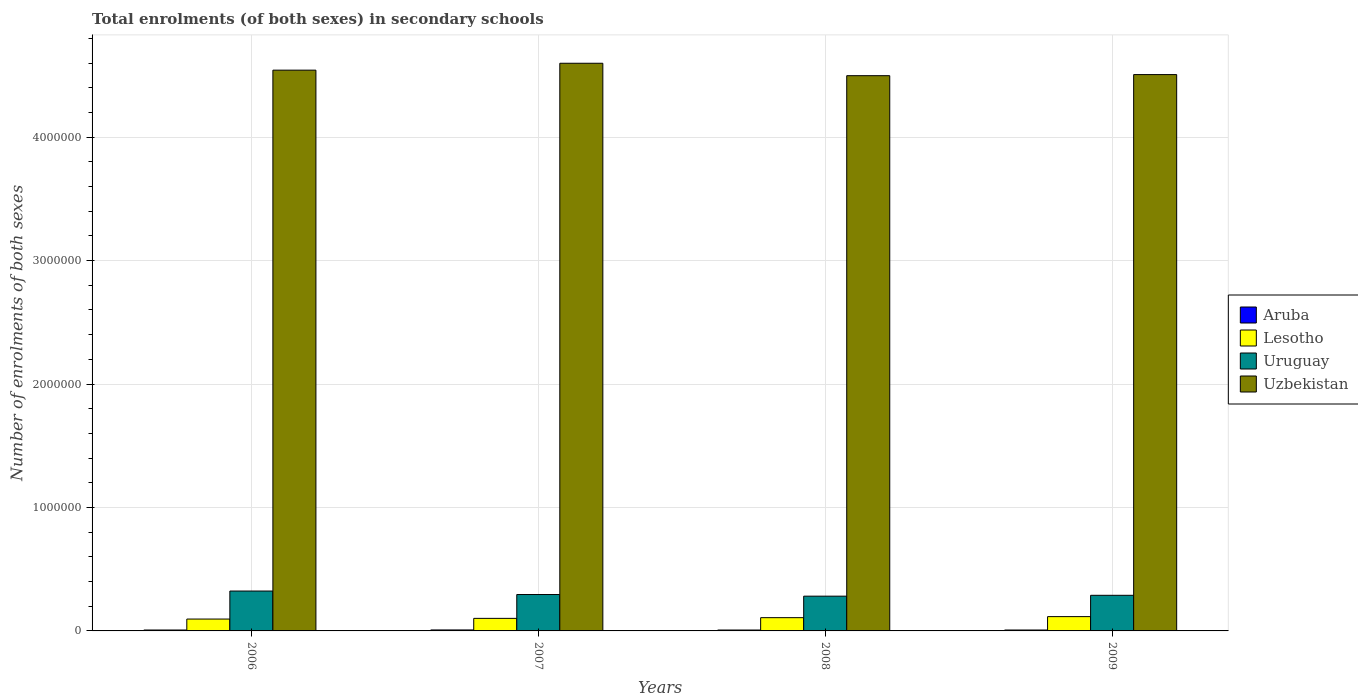How many different coloured bars are there?
Your answer should be compact. 4. In how many cases, is the number of bars for a given year not equal to the number of legend labels?
Your answer should be compact. 0. What is the number of enrolments in secondary schools in Uruguay in 2009?
Provide a short and direct response. 2.88e+05. Across all years, what is the maximum number of enrolments in secondary schools in Uzbekistan?
Your answer should be compact. 4.60e+06. Across all years, what is the minimum number of enrolments in secondary schools in Uzbekistan?
Ensure brevity in your answer.  4.50e+06. In which year was the number of enrolments in secondary schools in Uruguay maximum?
Offer a very short reply. 2006. What is the total number of enrolments in secondary schools in Lesotho in the graph?
Your answer should be compact. 4.21e+05. What is the difference between the number of enrolments in secondary schools in Uzbekistan in 2007 and that in 2008?
Your answer should be very brief. 1.01e+05. What is the difference between the number of enrolments in secondary schools in Lesotho in 2007 and the number of enrolments in secondary schools in Uzbekistan in 2008?
Your answer should be very brief. -4.40e+06. What is the average number of enrolments in secondary schools in Lesotho per year?
Your response must be concise. 1.05e+05. In the year 2008, what is the difference between the number of enrolments in secondary schools in Uruguay and number of enrolments in secondary schools in Lesotho?
Your answer should be very brief. 1.74e+05. What is the ratio of the number of enrolments in secondary schools in Lesotho in 2007 to that in 2008?
Keep it short and to the point. 0.95. What is the difference between the highest and the second highest number of enrolments in secondary schools in Uruguay?
Your answer should be compact. 2.82e+04. What is the difference between the highest and the lowest number of enrolments in secondary schools in Uruguay?
Keep it short and to the point. 4.14e+04. In how many years, is the number of enrolments in secondary schools in Aruba greater than the average number of enrolments in secondary schools in Aruba taken over all years?
Your response must be concise. 1. Is the sum of the number of enrolments in secondary schools in Lesotho in 2008 and 2009 greater than the maximum number of enrolments in secondary schools in Uruguay across all years?
Offer a very short reply. No. What does the 2nd bar from the left in 2008 represents?
Provide a short and direct response. Lesotho. What does the 2nd bar from the right in 2007 represents?
Offer a terse response. Uruguay. How many bars are there?
Provide a succinct answer. 16. Are all the bars in the graph horizontal?
Your answer should be compact. No. What is the difference between two consecutive major ticks on the Y-axis?
Provide a short and direct response. 1.00e+06. Are the values on the major ticks of Y-axis written in scientific E-notation?
Make the answer very short. No. How many legend labels are there?
Make the answer very short. 4. What is the title of the graph?
Give a very brief answer. Total enrolments (of both sexes) in secondary schools. Does "Denmark" appear as one of the legend labels in the graph?
Offer a terse response. No. What is the label or title of the X-axis?
Offer a terse response. Years. What is the label or title of the Y-axis?
Offer a terse response. Number of enrolments of both sexes. What is the Number of enrolments of both sexes of Aruba in 2006?
Provide a short and direct response. 7439. What is the Number of enrolments of both sexes of Lesotho in 2006?
Your response must be concise. 9.61e+04. What is the Number of enrolments of both sexes of Uruguay in 2006?
Give a very brief answer. 3.23e+05. What is the Number of enrolments of both sexes in Uzbekistan in 2006?
Offer a very short reply. 4.54e+06. What is the Number of enrolments of both sexes of Aruba in 2007?
Ensure brevity in your answer.  7853. What is the Number of enrolments of both sexes of Lesotho in 2007?
Offer a terse response. 1.02e+05. What is the Number of enrolments of both sexes in Uruguay in 2007?
Your response must be concise. 2.95e+05. What is the Number of enrolments of both sexes in Uzbekistan in 2007?
Offer a very short reply. 4.60e+06. What is the Number of enrolments of both sexes in Aruba in 2008?
Offer a terse response. 7270. What is the Number of enrolments of both sexes in Lesotho in 2008?
Give a very brief answer. 1.07e+05. What is the Number of enrolments of both sexes of Uruguay in 2008?
Provide a short and direct response. 2.82e+05. What is the Number of enrolments of both sexes in Uzbekistan in 2008?
Offer a terse response. 4.50e+06. What is the Number of enrolments of both sexes of Aruba in 2009?
Give a very brief answer. 7439. What is the Number of enrolments of both sexes of Lesotho in 2009?
Ensure brevity in your answer.  1.16e+05. What is the Number of enrolments of both sexes in Uruguay in 2009?
Your response must be concise. 2.88e+05. What is the Number of enrolments of both sexes of Uzbekistan in 2009?
Make the answer very short. 4.51e+06. Across all years, what is the maximum Number of enrolments of both sexes of Aruba?
Provide a short and direct response. 7853. Across all years, what is the maximum Number of enrolments of both sexes of Lesotho?
Your response must be concise. 1.16e+05. Across all years, what is the maximum Number of enrolments of both sexes in Uruguay?
Offer a terse response. 3.23e+05. Across all years, what is the maximum Number of enrolments of both sexes of Uzbekistan?
Offer a very short reply. 4.60e+06. Across all years, what is the minimum Number of enrolments of both sexes in Aruba?
Ensure brevity in your answer.  7270. Across all years, what is the minimum Number of enrolments of both sexes of Lesotho?
Your answer should be very brief. 9.61e+04. Across all years, what is the minimum Number of enrolments of both sexes of Uruguay?
Make the answer very short. 2.82e+05. Across all years, what is the minimum Number of enrolments of both sexes of Uzbekistan?
Give a very brief answer. 4.50e+06. What is the total Number of enrolments of both sexes of Aruba in the graph?
Keep it short and to the point. 3.00e+04. What is the total Number of enrolments of both sexes of Lesotho in the graph?
Keep it short and to the point. 4.21e+05. What is the total Number of enrolments of both sexes of Uruguay in the graph?
Provide a succinct answer. 1.19e+06. What is the total Number of enrolments of both sexes in Uzbekistan in the graph?
Your response must be concise. 1.81e+07. What is the difference between the Number of enrolments of both sexes of Aruba in 2006 and that in 2007?
Your answer should be compact. -414. What is the difference between the Number of enrolments of both sexes of Lesotho in 2006 and that in 2007?
Your answer should be very brief. -5665. What is the difference between the Number of enrolments of both sexes in Uruguay in 2006 and that in 2007?
Your answer should be very brief. 2.82e+04. What is the difference between the Number of enrolments of both sexes of Uzbekistan in 2006 and that in 2007?
Your answer should be very brief. -5.59e+04. What is the difference between the Number of enrolments of both sexes of Aruba in 2006 and that in 2008?
Make the answer very short. 169. What is the difference between the Number of enrolments of both sexes of Lesotho in 2006 and that in 2008?
Provide a succinct answer. -1.12e+04. What is the difference between the Number of enrolments of both sexes in Uruguay in 2006 and that in 2008?
Ensure brevity in your answer.  4.14e+04. What is the difference between the Number of enrolments of both sexes in Uzbekistan in 2006 and that in 2008?
Your answer should be very brief. 4.48e+04. What is the difference between the Number of enrolments of both sexes of Lesotho in 2006 and that in 2009?
Offer a very short reply. -1.97e+04. What is the difference between the Number of enrolments of both sexes in Uruguay in 2006 and that in 2009?
Provide a short and direct response. 3.45e+04. What is the difference between the Number of enrolments of both sexes of Uzbekistan in 2006 and that in 2009?
Offer a terse response. 3.59e+04. What is the difference between the Number of enrolments of both sexes of Aruba in 2007 and that in 2008?
Make the answer very short. 583. What is the difference between the Number of enrolments of both sexes in Lesotho in 2007 and that in 2008?
Provide a succinct answer. -5584. What is the difference between the Number of enrolments of both sexes of Uruguay in 2007 and that in 2008?
Offer a very short reply. 1.33e+04. What is the difference between the Number of enrolments of both sexes of Uzbekistan in 2007 and that in 2008?
Ensure brevity in your answer.  1.01e+05. What is the difference between the Number of enrolments of both sexes of Aruba in 2007 and that in 2009?
Ensure brevity in your answer.  414. What is the difference between the Number of enrolments of both sexes of Lesotho in 2007 and that in 2009?
Offer a terse response. -1.41e+04. What is the difference between the Number of enrolments of both sexes of Uruguay in 2007 and that in 2009?
Keep it short and to the point. 6361. What is the difference between the Number of enrolments of both sexes in Uzbekistan in 2007 and that in 2009?
Your answer should be very brief. 9.18e+04. What is the difference between the Number of enrolments of both sexes of Aruba in 2008 and that in 2009?
Offer a terse response. -169. What is the difference between the Number of enrolments of both sexes in Lesotho in 2008 and that in 2009?
Give a very brief answer. -8483. What is the difference between the Number of enrolments of both sexes in Uruguay in 2008 and that in 2009?
Provide a short and direct response. -6898. What is the difference between the Number of enrolments of both sexes in Uzbekistan in 2008 and that in 2009?
Ensure brevity in your answer.  -8854. What is the difference between the Number of enrolments of both sexes of Aruba in 2006 and the Number of enrolments of both sexes of Lesotho in 2007?
Your answer should be compact. -9.43e+04. What is the difference between the Number of enrolments of both sexes in Aruba in 2006 and the Number of enrolments of both sexes in Uruguay in 2007?
Offer a very short reply. -2.87e+05. What is the difference between the Number of enrolments of both sexes in Aruba in 2006 and the Number of enrolments of both sexes in Uzbekistan in 2007?
Provide a succinct answer. -4.59e+06. What is the difference between the Number of enrolments of both sexes of Lesotho in 2006 and the Number of enrolments of both sexes of Uruguay in 2007?
Your answer should be very brief. -1.99e+05. What is the difference between the Number of enrolments of both sexes in Lesotho in 2006 and the Number of enrolments of both sexes in Uzbekistan in 2007?
Offer a terse response. -4.50e+06. What is the difference between the Number of enrolments of both sexes in Uruguay in 2006 and the Number of enrolments of both sexes in Uzbekistan in 2007?
Make the answer very short. -4.28e+06. What is the difference between the Number of enrolments of both sexes in Aruba in 2006 and the Number of enrolments of both sexes in Lesotho in 2008?
Ensure brevity in your answer.  -9.99e+04. What is the difference between the Number of enrolments of both sexes in Aruba in 2006 and the Number of enrolments of both sexes in Uruguay in 2008?
Provide a succinct answer. -2.74e+05. What is the difference between the Number of enrolments of both sexes in Aruba in 2006 and the Number of enrolments of both sexes in Uzbekistan in 2008?
Your answer should be compact. -4.49e+06. What is the difference between the Number of enrolments of both sexes of Lesotho in 2006 and the Number of enrolments of both sexes of Uruguay in 2008?
Provide a short and direct response. -1.86e+05. What is the difference between the Number of enrolments of both sexes in Lesotho in 2006 and the Number of enrolments of both sexes in Uzbekistan in 2008?
Make the answer very short. -4.40e+06. What is the difference between the Number of enrolments of both sexes of Uruguay in 2006 and the Number of enrolments of both sexes of Uzbekistan in 2008?
Make the answer very short. -4.17e+06. What is the difference between the Number of enrolments of both sexes in Aruba in 2006 and the Number of enrolments of both sexes in Lesotho in 2009?
Ensure brevity in your answer.  -1.08e+05. What is the difference between the Number of enrolments of both sexes of Aruba in 2006 and the Number of enrolments of both sexes of Uruguay in 2009?
Ensure brevity in your answer.  -2.81e+05. What is the difference between the Number of enrolments of both sexes of Aruba in 2006 and the Number of enrolments of both sexes of Uzbekistan in 2009?
Your answer should be very brief. -4.50e+06. What is the difference between the Number of enrolments of both sexes of Lesotho in 2006 and the Number of enrolments of both sexes of Uruguay in 2009?
Your answer should be very brief. -1.92e+05. What is the difference between the Number of enrolments of both sexes of Lesotho in 2006 and the Number of enrolments of both sexes of Uzbekistan in 2009?
Keep it short and to the point. -4.41e+06. What is the difference between the Number of enrolments of both sexes of Uruguay in 2006 and the Number of enrolments of both sexes of Uzbekistan in 2009?
Give a very brief answer. -4.18e+06. What is the difference between the Number of enrolments of both sexes of Aruba in 2007 and the Number of enrolments of both sexes of Lesotho in 2008?
Offer a terse response. -9.95e+04. What is the difference between the Number of enrolments of both sexes in Aruba in 2007 and the Number of enrolments of both sexes in Uruguay in 2008?
Your answer should be very brief. -2.74e+05. What is the difference between the Number of enrolments of both sexes in Aruba in 2007 and the Number of enrolments of both sexes in Uzbekistan in 2008?
Your answer should be very brief. -4.49e+06. What is the difference between the Number of enrolments of both sexes in Lesotho in 2007 and the Number of enrolments of both sexes in Uruguay in 2008?
Provide a short and direct response. -1.80e+05. What is the difference between the Number of enrolments of both sexes of Lesotho in 2007 and the Number of enrolments of both sexes of Uzbekistan in 2008?
Your answer should be compact. -4.40e+06. What is the difference between the Number of enrolments of both sexes in Uruguay in 2007 and the Number of enrolments of both sexes in Uzbekistan in 2008?
Give a very brief answer. -4.20e+06. What is the difference between the Number of enrolments of both sexes in Aruba in 2007 and the Number of enrolments of both sexes in Lesotho in 2009?
Your answer should be compact. -1.08e+05. What is the difference between the Number of enrolments of both sexes of Aruba in 2007 and the Number of enrolments of both sexes of Uruguay in 2009?
Your answer should be very brief. -2.81e+05. What is the difference between the Number of enrolments of both sexes of Aruba in 2007 and the Number of enrolments of both sexes of Uzbekistan in 2009?
Keep it short and to the point. -4.50e+06. What is the difference between the Number of enrolments of both sexes of Lesotho in 2007 and the Number of enrolments of both sexes of Uruguay in 2009?
Your answer should be very brief. -1.87e+05. What is the difference between the Number of enrolments of both sexes in Lesotho in 2007 and the Number of enrolments of both sexes in Uzbekistan in 2009?
Make the answer very short. -4.40e+06. What is the difference between the Number of enrolments of both sexes of Uruguay in 2007 and the Number of enrolments of both sexes of Uzbekistan in 2009?
Offer a very short reply. -4.21e+06. What is the difference between the Number of enrolments of both sexes in Aruba in 2008 and the Number of enrolments of both sexes in Lesotho in 2009?
Keep it short and to the point. -1.09e+05. What is the difference between the Number of enrolments of both sexes of Aruba in 2008 and the Number of enrolments of both sexes of Uruguay in 2009?
Ensure brevity in your answer.  -2.81e+05. What is the difference between the Number of enrolments of both sexes in Aruba in 2008 and the Number of enrolments of both sexes in Uzbekistan in 2009?
Keep it short and to the point. -4.50e+06. What is the difference between the Number of enrolments of both sexes of Lesotho in 2008 and the Number of enrolments of both sexes of Uruguay in 2009?
Provide a short and direct response. -1.81e+05. What is the difference between the Number of enrolments of both sexes of Lesotho in 2008 and the Number of enrolments of both sexes of Uzbekistan in 2009?
Provide a short and direct response. -4.40e+06. What is the difference between the Number of enrolments of both sexes of Uruguay in 2008 and the Number of enrolments of both sexes of Uzbekistan in 2009?
Provide a short and direct response. -4.22e+06. What is the average Number of enrolments of both sexes of Aruba per year?
Your response must be concise. 7500.25. What is the average Number of enrolments of both sexes of Lesotho per year?
Your response must be concise. 1.05e+05. What is the average Number of enrolments of both sexes in Uruguay per year?
Ensure brevity in your answer.  2.97e+05. What is the average Number of enrolments of both sexes of Uzbekistan per year?
Your answer should be very brief. 4.54e+06. In the year 2006, what is the difference between the Number of enrolments of both sexes in Aruba and Number of enrolments of both sexes in Lesotho?
Keep it short and to the point. -8.86e+04. In the year 2006, what is the difference between the Number of enrolments of both sexes in Aruba and Number of enrolments of both sexes in Uruguay?
Offer a terse response. -3.16e+05. In the year 2006, what is the difference between the Number of enrolments of both sexes of Aruba and Number of enrolments of both sexes of Uzbekistan?
Your answer should be compact. -4.53e+06. In the year 2006, what is the difference between the Number of enrolments of both sexes in Lesotho and Number of enrolments of both sexes in Uruguay?
Make the answer very short. -2.27e+05. In the year 2006, what is the difference between the Number of enrolments of both sexes of Lesotho and Number of enrolments of both sexes of Uzbekistan?
Your response must be concise. -4.45e+06. In the year 2006, what is the difference between the Number of enrolments of both sexes in Uruguay and Number of enrolments of both sexes in Uzbekistan?
Make the answer very short. -4.22e+06. In the year 2007, what is the difference between the Number of enrolments of both sexes of Aruba and Number of enrolments of both sexes of Lesotho?
Your answer should be very brief. -9.39e+04. In the year 2007, what is the difference between the Number of enrolments of both sexes in Aruba and Number of enrolments of both sexes in Uruguay?
Offer a terse response. -2.87e+05. In the year 2007, what is the difference between the Number of enrolments of both sexes of Aruba and Number of enrolments of both sexes of Uzbekistan?
Make the answer very short. -4.59e+06. In the year 2007, what is the difference between the Number of enrolments of both sexes in Lesotho and Number of enrolments of both sexes in Uruguay?
Give a very brief answer. -1.93e+05. In the year 2007, what is the difference between the Number of enrolments of both sexes of Lesotho and Number of enrolments of both sexes of Uzbekistan?
Keep it short and to the point. -4.50e+06. In the year 2007, what is the difference between the Number of enrolments of both sexes of Uruguay and Number of enrolments of both sexes of Uzbekistan?
Provide a succinct answer. -4.30e+06. In the year 2008, what is the difference between the Number of enrolments of both sexes of Aruba and Number of enrolments of both sexes of Lesotho?
Provide a short and direct response. -1.00e+05. In the year 2008, what is the difference between the Number of enrolments of both sexes in Aruba and Number of enrolments of both sexes in Uruguay?
Your answer should be very brief. -2.74e+05. In the year 2008, what is the difference between the Number of enrolments of both sexes in Aruba and Number of enrolments of both sexes in Uzbekistan?
Give a very brief answer. -4.49e+06. In the year 2008, what is the difference between the Number of enrolments of both sexes of Lesotho and Number of enrolments of both sexes of Uruguay?
Ensure brevity in your answer.  -1.74e+05. In the year 2008, what is the difference between the Number of enrolments of both sexes of Lesotho and Number of enrolments of both sexes of Uzbekistan?
Keep it short and to the point. -4.39e+06. In the year 2008, what is the difference between the Number of enrolments of both sexes in Uruguay and Number of enrolments of both sexes in Uzbekistan?
Give a very brief answer. -4.22e+06. In the year 2009, what is the difference between the Number of enrolments of both sexes in Aruba and Number of enrolments of both sexes in Lesotho?
Offer a very short reply. -1.08e+05. In the year 2009, what is the difference between the Number of enrolments of both sexes in Aruba and Number of enrolments of both sexes in Uruguay?
Provide a succinct answer. -2.81e+05. In the year 2009, what is the difference between the Number of enrolments of both sexes of Aruba and Number of enrolments of both sexes of Uzbekistan?
Offer a terse response. -4.50e+06. In the year 2009, what is the difference between the Number of enrolments of both sexes of Lesotho and Number of enrolments of both sexes of Uruguay?
Your response must be concise. -1.73e+05. In the year 2009, what is the difference between the Number of enrolments of both sexes in Lesotho and Number of enrolments of both sexes in Uzbekistan?
Provide a succinct answer. -4.39e+06. In the year 2009, what is the difference between the Number of enrolments of both sexes of Uruguay and Number of enrolments of both sexes of Uzbekistan?
Make the answer very short. -4.22e+06. What is the ratio of the Number of enrolments of both sexes in Aruba in 2006 to that in 2007?
Your response must be concise. 0.95. What is the ratio of the Number of enrolments of both sexes of Lesotho in 2006 to that in 2007?
Your answer should be compact. 0.94. What is the ratio of the Number of enrolments of both sexes of Uruguay in 2006 to that in 2007?
Keep it short and to the point. 1.1. What is the ratio of the Number of enrolments of both sexes of Uzbekistan in 2006 to that in 2007?
Provide a short and direct response. 0.99. What is the ratio of the Number of enrolments of both sexes in Aruba in 2006 to that in 2008?
Give a very brief answer. 1.02. What is the ratio of the Number of enrolments of both sexes in Lesotho in 2006 to that in 2008?
Provide a succinct answer. 0.9. What is the ratio of the Number of enrolments of both sexes of Uruguay in 2006 to that in 2008?
Offer a terse response. 1.15. What is the ratio of the Number of enrolments of both sexes of Uzbekistan in 2006 to that in 2008?
Provide a short and direct response. 1.01. What is the ratio of the Number of enrolments of both sexes of Aruba in 2006 to that in 2009?
Your response must be concise. 1. What is the ratio of the Number of enrolments of both sexes of Lesotho in 2006 to that in 2009?
Ensure brevity in your answer.  0.83. What is the ratio of the Number of enrolments of both sexes in Uruguay in 2006 to that in 2009?
Provide a succinct answer. 1.12. What is the ratio of the Number of enrolments of both sexes in Uzbekistan in 2006 to that in 2009?
Your response must be concise. 1.01. What is the ratio of the Number of enrolments of both sexes of Aruba in 2007 to that in 2008?
Your answer should be very brief. 1.08. What is the ratio of the Number of enrolments of both sexes in Lesotho in 2007 to that in 2008?
Provide a short and direct response. 0.95. What is the ratio of the Number of enrolments of both sexes in Uruguay in 2007 to that in 2008?
Offer a very short reply. 1.05. What is the ratio of the Number of enrolments of both sexes of Uzbekistan in 2007 to that in 2008?
Keep it short and to the point. 1.02. What is the ratio of the Number of enrolments of both sexes in Aruba in 2007 to that in 2009?
Your answer should be compact. 1.06. What is the ratio of the Number of enrolments of both sexes of Lesotho in 2007 to that in 2009?
Offer a very short reply. 0.88. What is the ratio of the Number of enrolments of both sexes of Uruguay in 2007 to that in 2009?
Your response must be concise. 1.02. What is the ratio of the Number of enrolments of both sexes of Uzbekistan in 2007 to that in 2009?
Provide a succinct answer. 1.02. What is the ratio of the Number of enrolments of both sexes of Aruba in 2008 to that in 2009?
Provide a succinct answer. 0.98. What is the ratio of the Number of enrolments of both sexes in Lesotho in 2008 to that in 2009?
Keep it short and to the point. 0.93. What is the ratio of the Number of enrolments of both sexes in Uruguay in 2008 to that in 2009?
Make the answer very short. 0.98. What is the ratio of the Number of enrolments of both sexes in Uzbekistan in 2008 to that in 2009?
Your answer should be compact. 1. What is the difference between the highest and the second highest Number of enrolments of both sexes in Aruba?
Ensure brevity in your answer.  414. What is the difference between the highest and the second highest Number of enrolments of both sexes of Lesotho?
Your response must be concise. 8483. What is the difference between the highest and the second highest Number of enrolments of both sexes in Uruguay?
Make the answer very short. 2.82e+04. What is the difference between the highest and the second highest Number of enrolments of both sexes of Uzbekistan?
Your answer should be compact. 5.59e+04. What is the difference between the highest and the lowest Number of enrolments of both sexes in Aruba?
Give a very brief answer. 583. What is the difference between the highest and the lowest Number of enrolments of both sexes of Lesotho?
Provide a succinct answer. 1.97e+04. What is the difference between the highest and the lowest Number of enrolments of both sexes of Uruguay?
Make the answer very short. 4.14e+04. What is the difference between the highest and the lowest Number of enrolments of both sexes in Uzbekistan?
Offer a terse response. 1.01e+05. 